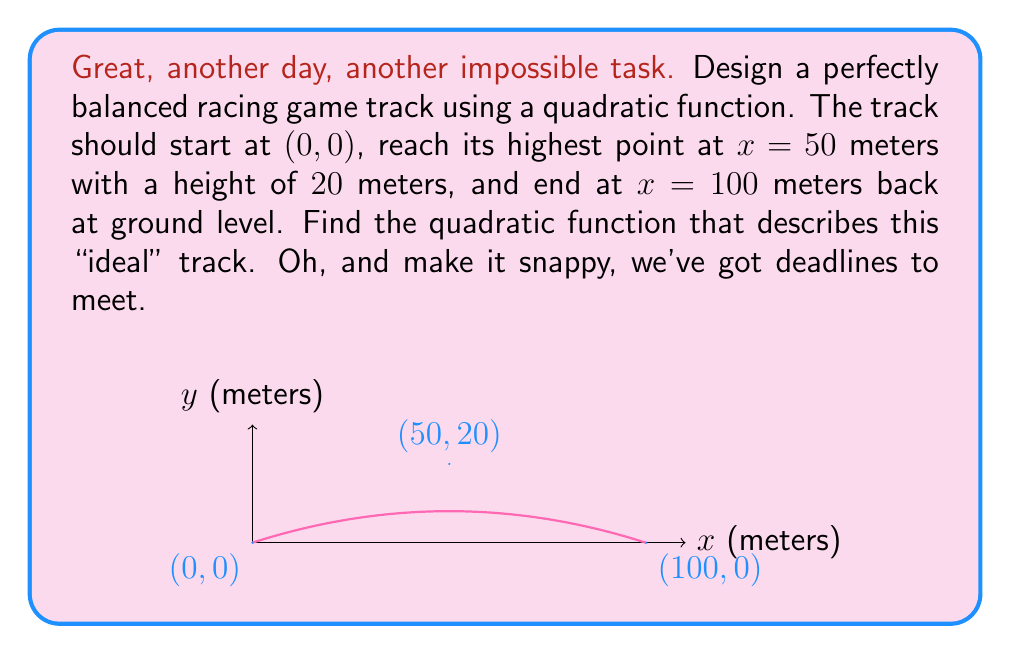Teach me how to tackle this problem. Alright, let's get this over with. We're looking for a quadratic function in the form $y = ax^2 + bx + c$.

1) Since the track starts at (0, 0), we know $c = 0$.

2) The vertex of the parabola is at (50, 20), so we can use the vertex form:
   $y = a(x - 50)^2 + 20$

3) We know the track ends at (100, 0), so:
   $0 = a(100 - 50)^2 + 20$
   $0 = a(50)^2 + 20$
   $-20 = 2500a$
   $a = -\frac{20}{2500} = -0.008$

4) Now we have:
   $y = -0.008(x - 50)^2 + 20$

5) Expand this:
   $y = -0.008(x^2 - 100x + 2500) + 20$
   $y = -0.008x^2 + 0.8x - 20 + 20$

6) Simplify:
   $y = -0.008x^2 + 0.8x$

7) To make it look nicer (because apparently that matters), let's factor out 0.008:
   $y = 0.008(-x^2 + 100x)$

There. A perfect, "ideal" track. I'm sure the players will absolutely love it.
Answer: $y = 0.008(-x^2 + 100x)$ 